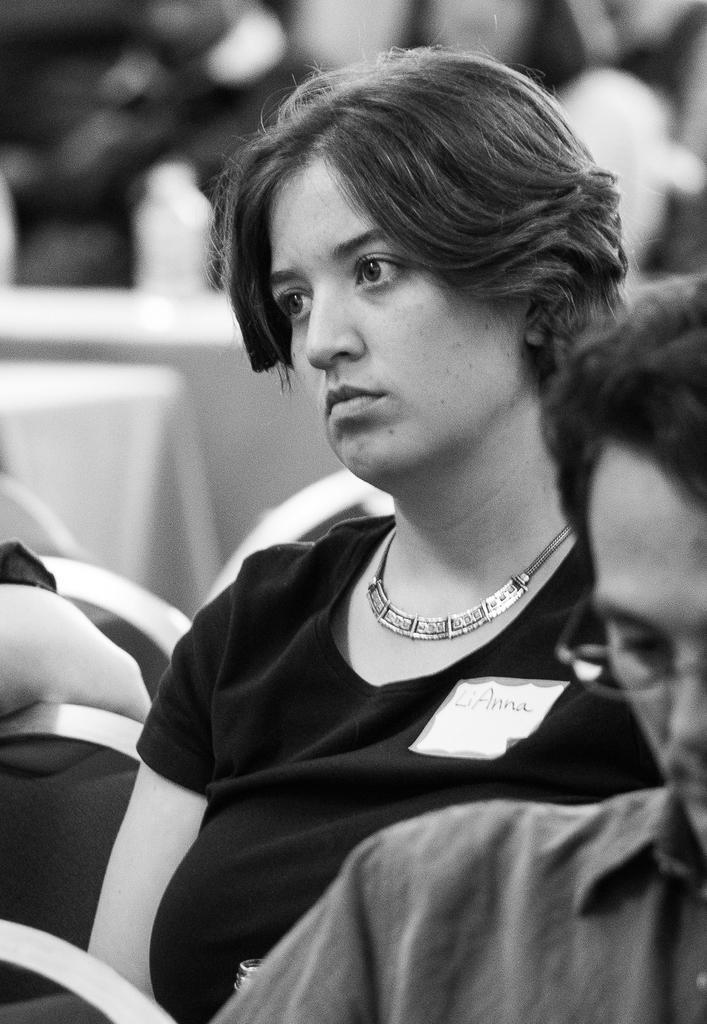Please provide a concise description of this image. It is a black and white image, there is a woman and she is wearing a badge to her dress and looking at something and in front of the woman on the right side there is another man and his face is partially visible, he is wearing spectacles. 